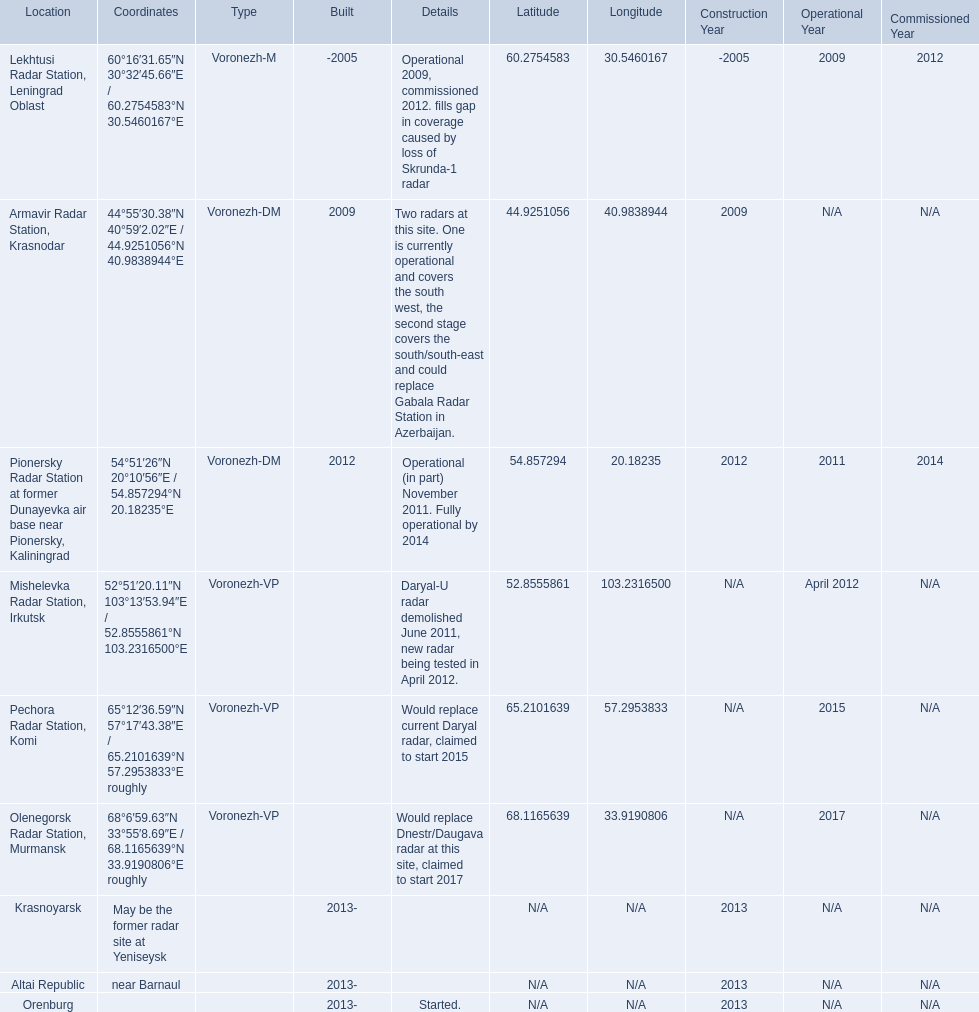Where is each radar? Lekhtusi Radar Station, Leningrad Oblast, Armavir Radar Station, Krasnodar, Pionersky Radar Station at former Dunayevka air base near Pionersky, Kaliningrad, Mishelevka Radar Station, Irkutsk, Pechora Radar Station, Komi, Olenegorsk Radar Station, Murmansk, Krasnoyarsk, Altai Republic, Orenburg. What are the details of each radar? Operational 2009, commissioned 2012. fills gap in coverage caused by loss of Skrunda-1 radar, Two radars at this site. One is currently operational and covers the south west, the second stage covers the south/south-east and could replace Gabala Radar Station in Azerbaijan., Operational (in part) November 2011. Fully operational by 2014, Daryal-U radar demolished June 2011, new radar being tested in April 2012., Would replace current Daryal radar, claimed to start 2015, Would replace Dnestr/Daugava radar at this site, claimed to start 2017, , , Started. Which radar is detailed to start in 2015? Pechora Radar Station, Komi. 